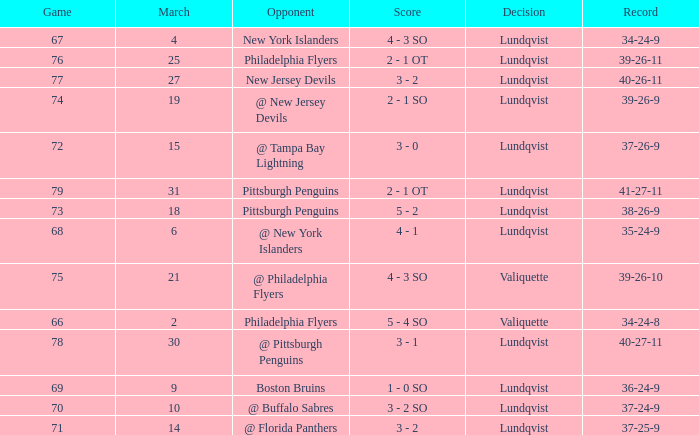Which opponent's march was 31? Pittsburgh Penguins. Help me parse the entirety of this table. {'header': ['Game', 'March', 'Opponent', 'Score', 'Decision', 'Record'], 'rows': [['67', '4', 'New York Islanders', '4 - 3 SO', 'Lundqvist', '34-24-9'], ['76', '25', 'Philadelphia Flyers', '2 - 1 OT', 'Lundqvist', '39-26-11'], ['77', '27', 'New Jersey Devils', '3 - 2', 'Lundqvist', '40-26-11'], ['74', '19', '@ New Jersey Devils', '2 - 1 SO', 'Lundqvist', '39-26-9'], ['72', '15', '@ Tampa Bay Lightning', '3 - 0', 'Lundqvist', '37-26-9'], ['79', '31', 'Pittsburgh Penguins', '2 - 1 OT', 'Lundqvist', '41-27-11'], ['73', '18', 'Pittsburgh Penguins', '5 - 2', 'Lundqvist', '38-26-9'], ['68', '6', '@ New York Islanders', '4 - 1', 'Lundqvist', '35-24-9'], ['75', '21', '@ Philadelphia Flyers', '4 - 3 SO', 'Valiquette', '39-26-10'], ['66', '2', 'Philadelphia Flyers', '5 - 4 SO', 'Valiquette', '34-24-8'], ['78', '30', '@ Pittsburgh Penguins', '3 - 1', 'Lundqvist', '40-27-11'], ['69', '9', 'Boston Bruins', '1 - 0 SO', 'Lundqvist', '36-24-9'], ['70', '10', '@ Buffalo Sabres', '3 - 2 SO', 'Lundqvist', '37-24-9'], ['71', '14', '@ Florida Panthers', '3 - 2', 'Lundqvist', '37-25-9']]} 